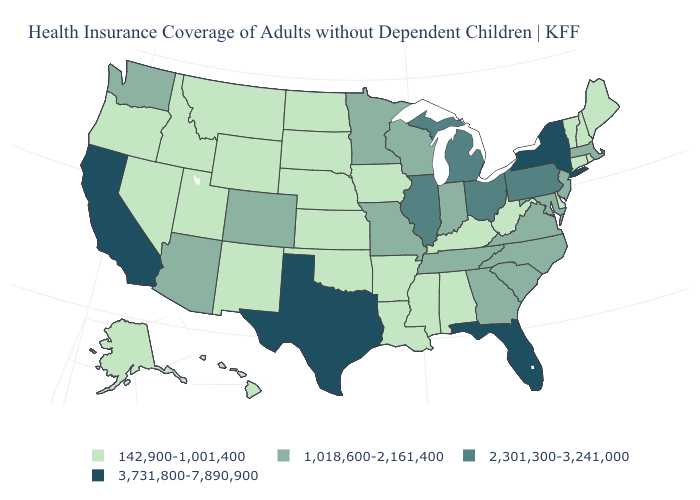Name the states that have a value in the range 1,018,600-2,161,400?
Concise answer only. Arizona, Colorado, Georgia, Indiana, Maryland, Massachusetts, Minnesota, Missouri, New Jersey, North Carolina, South Carolina, Tennessee, Virginia, Washington, Wisconsin. Name the states that have a value in the range 3,731,800-7,890,900?
Quick response, please. California, Florida, New York, Texas. Name the states that have a value in the range 142,900-1,001,400?
Write a very short answer. Alabama, Alaska, Arkansas, Connecticut, Delaware, Hawaii, Idaho, Iowa, Kansas, Kentucky, Louisiana, Maine, Mississippi, Montana, Nebraska, Nevada, New Hampshire, New Mexico, North Dakota, Oklahoma, Oregon, Rhode Island, South Dakota, Utah, Vermont, West Virginia, Wyoming. Among the states that border Michigan , does Ohio have the highest value?
Keep it brief. Yes. Name the states that have a value in the range 3,731,800-7,890,900?
Write a very short answer. California, Florida, New York, Texas. Does the first symbol in the legend represent the smallest category?
Write a very short answer. Yes. Which states have the highest value in the USA?
Give a very brief answer. California, Florida, New York, Texas. What is the value of Minnesota?
Concise answer only. 1,018,600-2,161,400. Name the states that have a value in the range 1,018,600-2,161,400?
Give a very brief answer. Arizona, Colorado, Georgia, Indiana, Maryland, Massachusetts, Minnesota, Missouri, New Jersey, North Carolina, South Carolina, Tennessee, Virginia, Washington, Wisconsin. Is the legend a continuous bar?
Keep it brief. No. What is the value of Pennsylvania?
Short answer required. 2,301,300-3,241,000. Among the states that border Illinois , does Indiana have the lowest value?
Concise answer only. No. What is the highest value in the West ?
Concise answer only. 3,731,800-7,890,900. What is the lowest value in states that border Massachusetts?
Concise answer only. 142,900-1,001,400. Among the states that border Florida , which have the lowest value?
Be succinct. Alabama. 